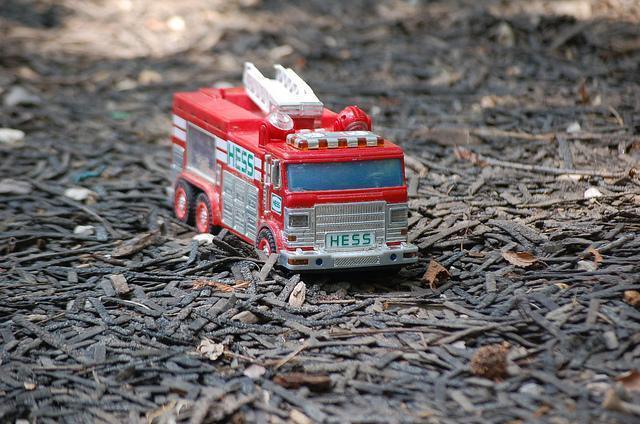How many airplanes are there?
Give a very brief answer. 0. 